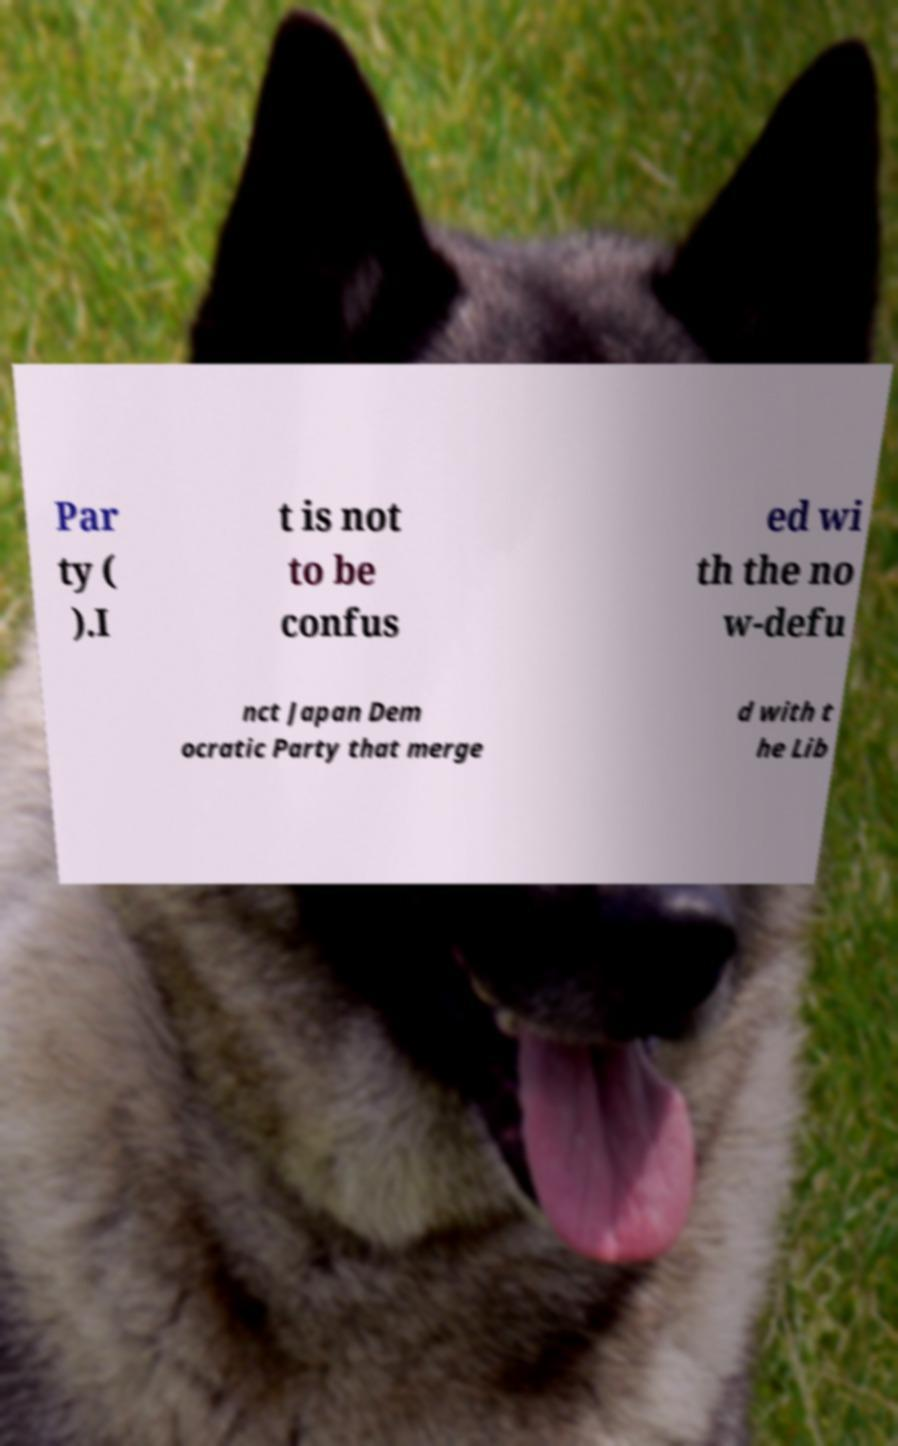Can you accurately transcribe the text from the provided image for me? Par ty ( ).I t is not to be confus ed wi th the no w-defu nct Japan Dem ocratic Party that merge d with t he Lib 